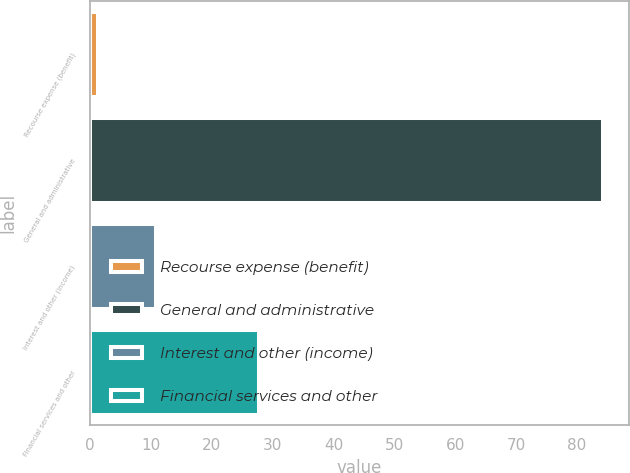<chart> <loc_0><loc_0><loc_500><loc_500><bar_chart><fcel>Recourse expense (benefit)<fcel>General and administrative<fcel>Interest and other (income)<fcel>Financial services and other<nl><fcel>1.3<fcel>84.3<fcel>10.8<fcel>27.8<nl></chart> 